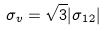<formula> <loc_0><loc_0><loc_500><loc_500>\sigma _ { v } = \sqrt { 3 } | \sigma _ { 1 2 } |</formula> 